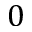<formula> <loc_0><loc_0><loc_500><loc_500>0</formula> 